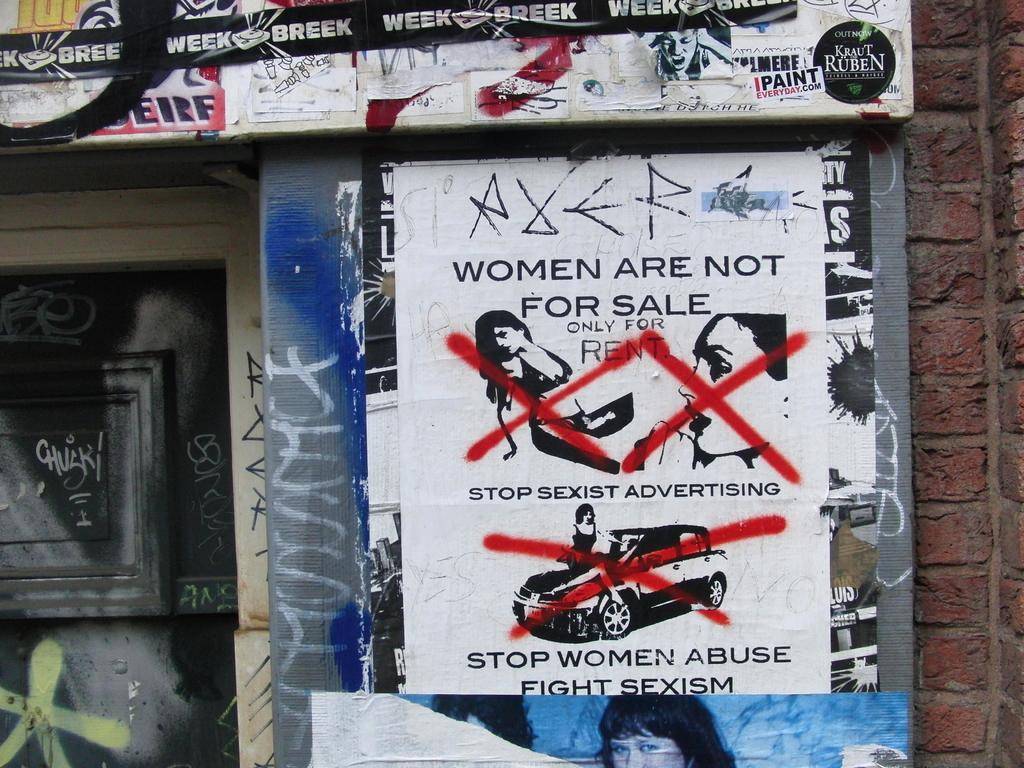In one or two sentences, can you explain what this image depicts? In this picture I can observe posters on the wall. I can observe some text in the posters. On the left side I can observe black color door. 